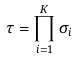Convert formula to latex. <formula><loc_0><loc_0><loc_500><loc_500>\tau = \prod _ { i = 1 } ^ { K } \sigma _ { i }</formula> 